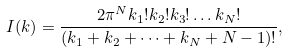Convert formula to latex. <formula><loc_0><loc_0><loc_500><loc_500>I ( k ) = \frac { 2 \pi ^ { N } k _ { 1 } ! k _ { 2 } ! k _ { 3 } ! \dots k _ { N } ! } { ( k _ { 1 } + k _ { 2 } + \dots + k _ { N } + N - 1 ) ! } ,</formula> 